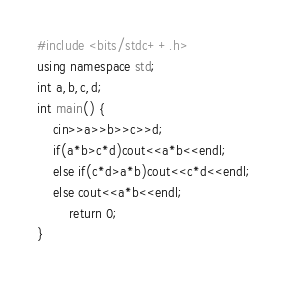Convert code to text. <code><loc_0><loc_0><loc_500><loc_500><_C++_>#include <bits/stdc++.h>
using namespace std;
int a,b,c,d;
int main() {
	cin>>a>>b>>c>>d;
	if(a*b>c*d)cout<<a*b<<endl;
	else if(c*d>a*b)cout<<c*d<<endl;
	else cout<<a*b<<endl;
		return 0;
}</code> 